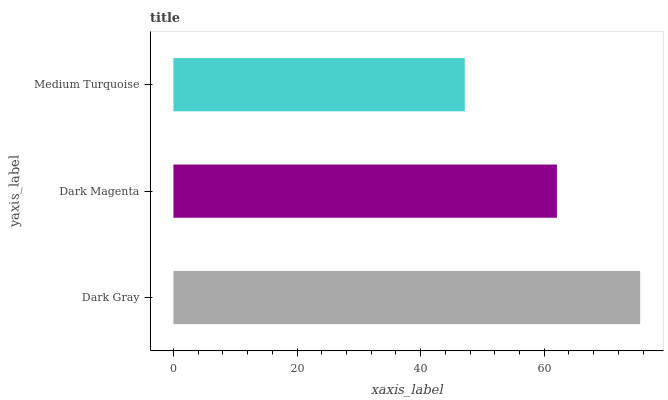Is Medium Turquoise the minimum?
Answer yes or no. Yes. Is Dark Gray the maximum?
Answer yes or no. Yes. Is Dark Magenta the minimum?
Answer yes or no. No. Is Dark Magenta the maximum?
Answer yes or no. No. Is Dark Gray greater than Dark Magenta?
Answer yes or no. Yes. Is Dark Magenta less than Dark Gray?
Answer yes or no. Yes. Is Dark Magenta greater than Dark Gray?
Answer yes or no. No. Is Dark Gray less than Dark Magenta?
Answer yes or no. No. Is Dark Magenta the high median?
Answer yes or no. Yes. Is Dark Magenta the low median?
Answer yes or no. Yes. Is Medium Turquoise the high median?
Answer yes or no. No. Is Medium Turquoise the low median?
Answer yes or no. No. 